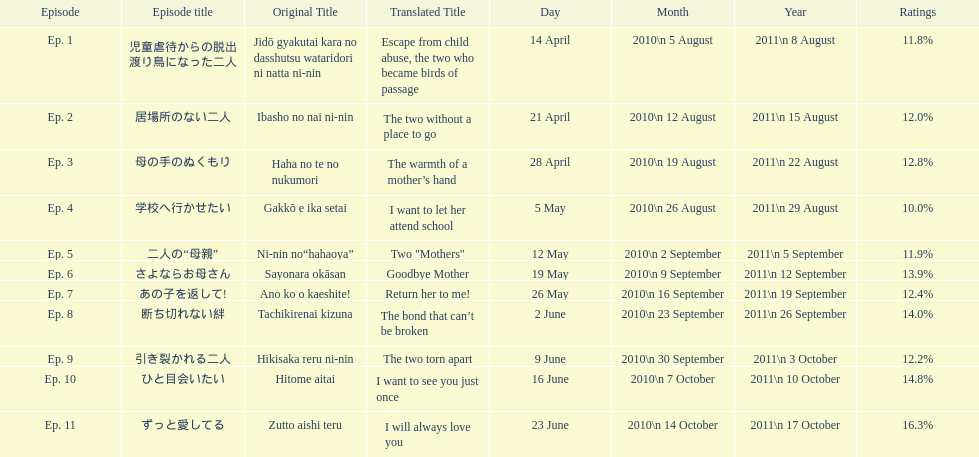How many episodes were broadcast in april 2010 in japan? 3. 